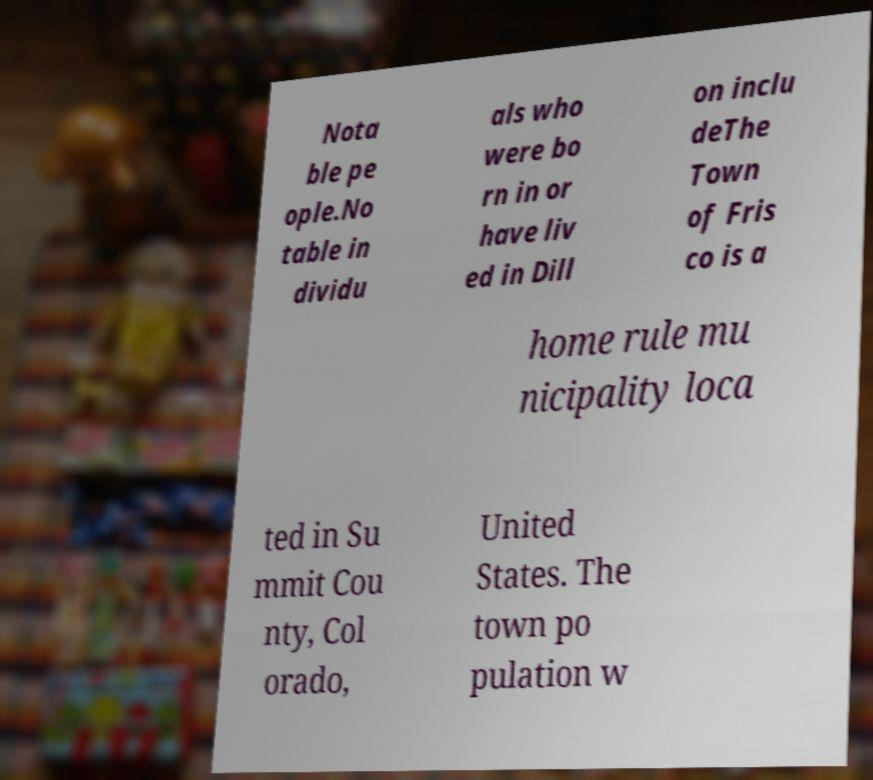What messages or text are displayed in this image? I need them in a readable, typed format. Nota ble pe ople.No table in dividu als who were bo rn in or have liv ed in Dill on inclu deThe Town of Fris co is a home rule mu nicipality loca ted in Su mmit Cou nty, Col orado, United States. The town po pulation w 